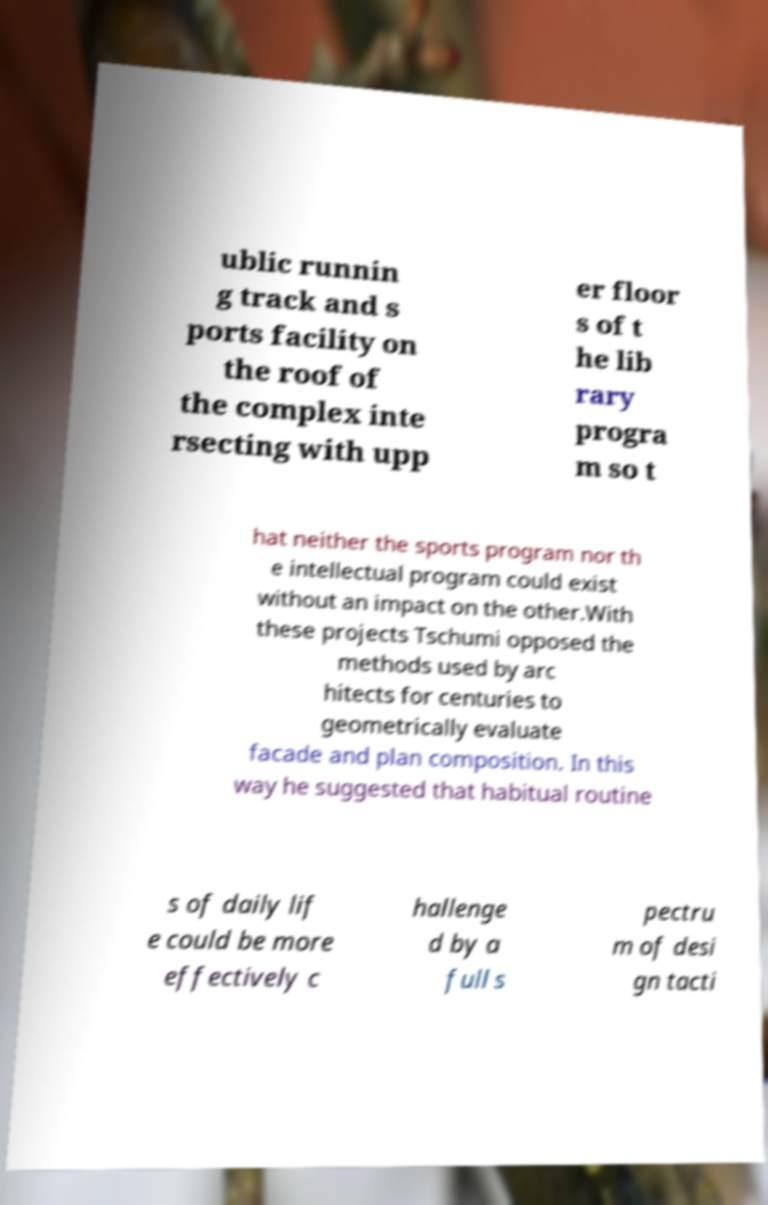For documentation purposes, I need the text within this image transcribed. Could you provide that? ublic runnin g track and s ports facility on the roof of the complex inte rsecting with upp er floor s of t he lib rary progra m so t hat neither the sports program nor th e intellectual program could exist without an impact on the other.With these projects Tschumi opposed the methods used by arc hitects for centuries to geometrically evaluate facade and plan composition. In this way he suggested that habitual routine s of daily lif e could be more effectively c hallenge d by a full s pectru m of desi gn tacti 